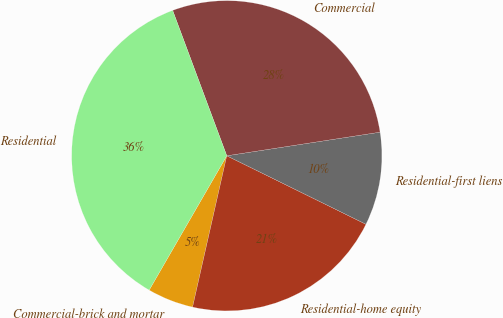Convert chart. <chart><loc_0><loc_0><loc_500><loc_500><pie_chart><fcel>Commercial-brick and mortar<fcel>Residential-home equity<fcel>Residential-first liens<fcel>Commercial<fcel>Residential<nl><fcel>4.8%<fcel>21.26%<fcel>9.71%<fcel>28.24%<fcel>35.99%<nl></chart> 